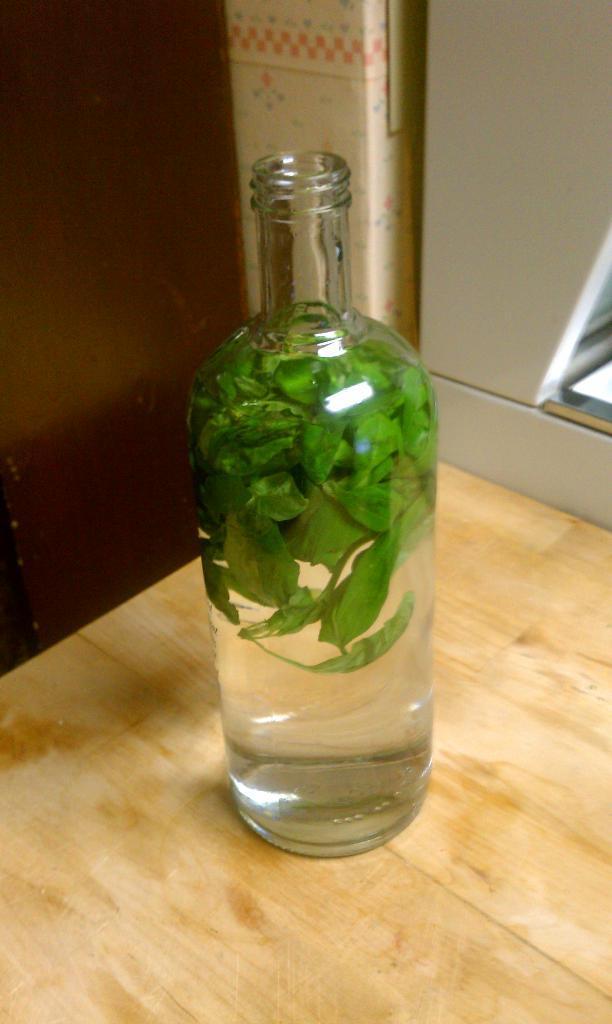What is in the bottle that is visible in the image? The bottle contains leaves in the image. Where is the bottle located in the image? The bottle is on a table in the image. What note is written on the sign in the image? There is no sign present in the image, so it is not possible to answer a question about a note written on it. 